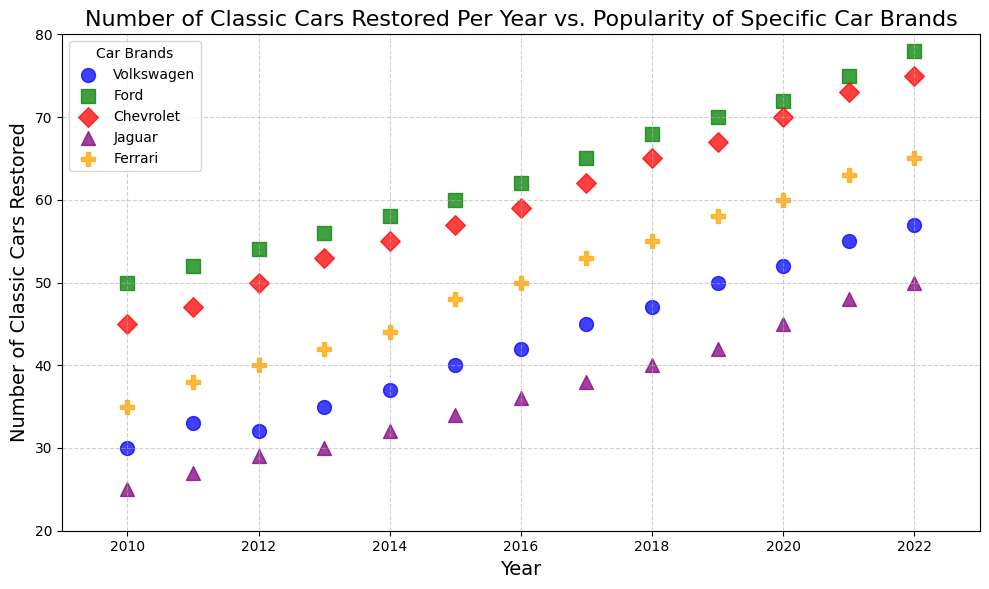What's the total number of classic cars restored in 2020 for all brands combined? First, locate the data points for the year 2020 for each car brand, then sum up their values: Volkswagen (52), Ford (72), Chevrolet (70), Jaguar (45), Ferrari (60). The total is 52 + 72 + 70 + 45 + 60 = 299.
Answer: 299 Which car brand had the highest number of classic cars restored in 2022? Look at the data points for the year 2022 and compare the numbers for each car brand: Volkswagen (57), Ford (78), Chevrolet (75), Jaguar (50), Ferrari (65). Ford has the highest number.
Answer: Ford Between which years did Jaguar see the biggest increase in the number of classic cars restored? Compare the data points for Jaguar across the years. The biggest increase is from 45 in 2020 to 48 in 2021, which is an increase of 3 cars.
Answer: 2020 to 2021 How does the number of classic cars restored by Volkswagen in 2011 compare to the same in 2015? For 2011, Volkswagen restored 33 cars, and in 2015, it restored 40 cars. Compare the numbers: 40 (2015) - 33 (2011) = 7 more cars in 2015.
Answer: 7 more cars What is the average number of classic cars restored per year for Ford between 2010 and 2022? Sum the values for Ford across the years 2010 to 2022 and divide by the number of years. (50 + 52 + 54 + 56 + 58 + 60 + 62 + 65 + 68 + 70 + 72 + 75 + 78) = 820, the average is 820/13 = 63.08.
Answer: 63.08 Which car brand showed a consistent increase in the number of classic cars restored from 2010 to 2022? Check the trend lines for all car brands. Ford shows a consistent increase from 50 in 2010 to 78 in 2022.
Answer: Ford What is the difference in the number of classic cars restored by Chevrolet between 2018 and 2019? Locate Chevrolet's data points for 2018 (65) and 2019 (67), and find the difference: 67 - 65 = 2.
Answer: 2 How many more classic cars did Ferrari restore in 2020 compared to Jaguar in the same year? Compare Ferrari's 2020 value (60) with Jaguar's 2020 value (45), and find the difference: 60 - 45 = 15.
Answer: 15 